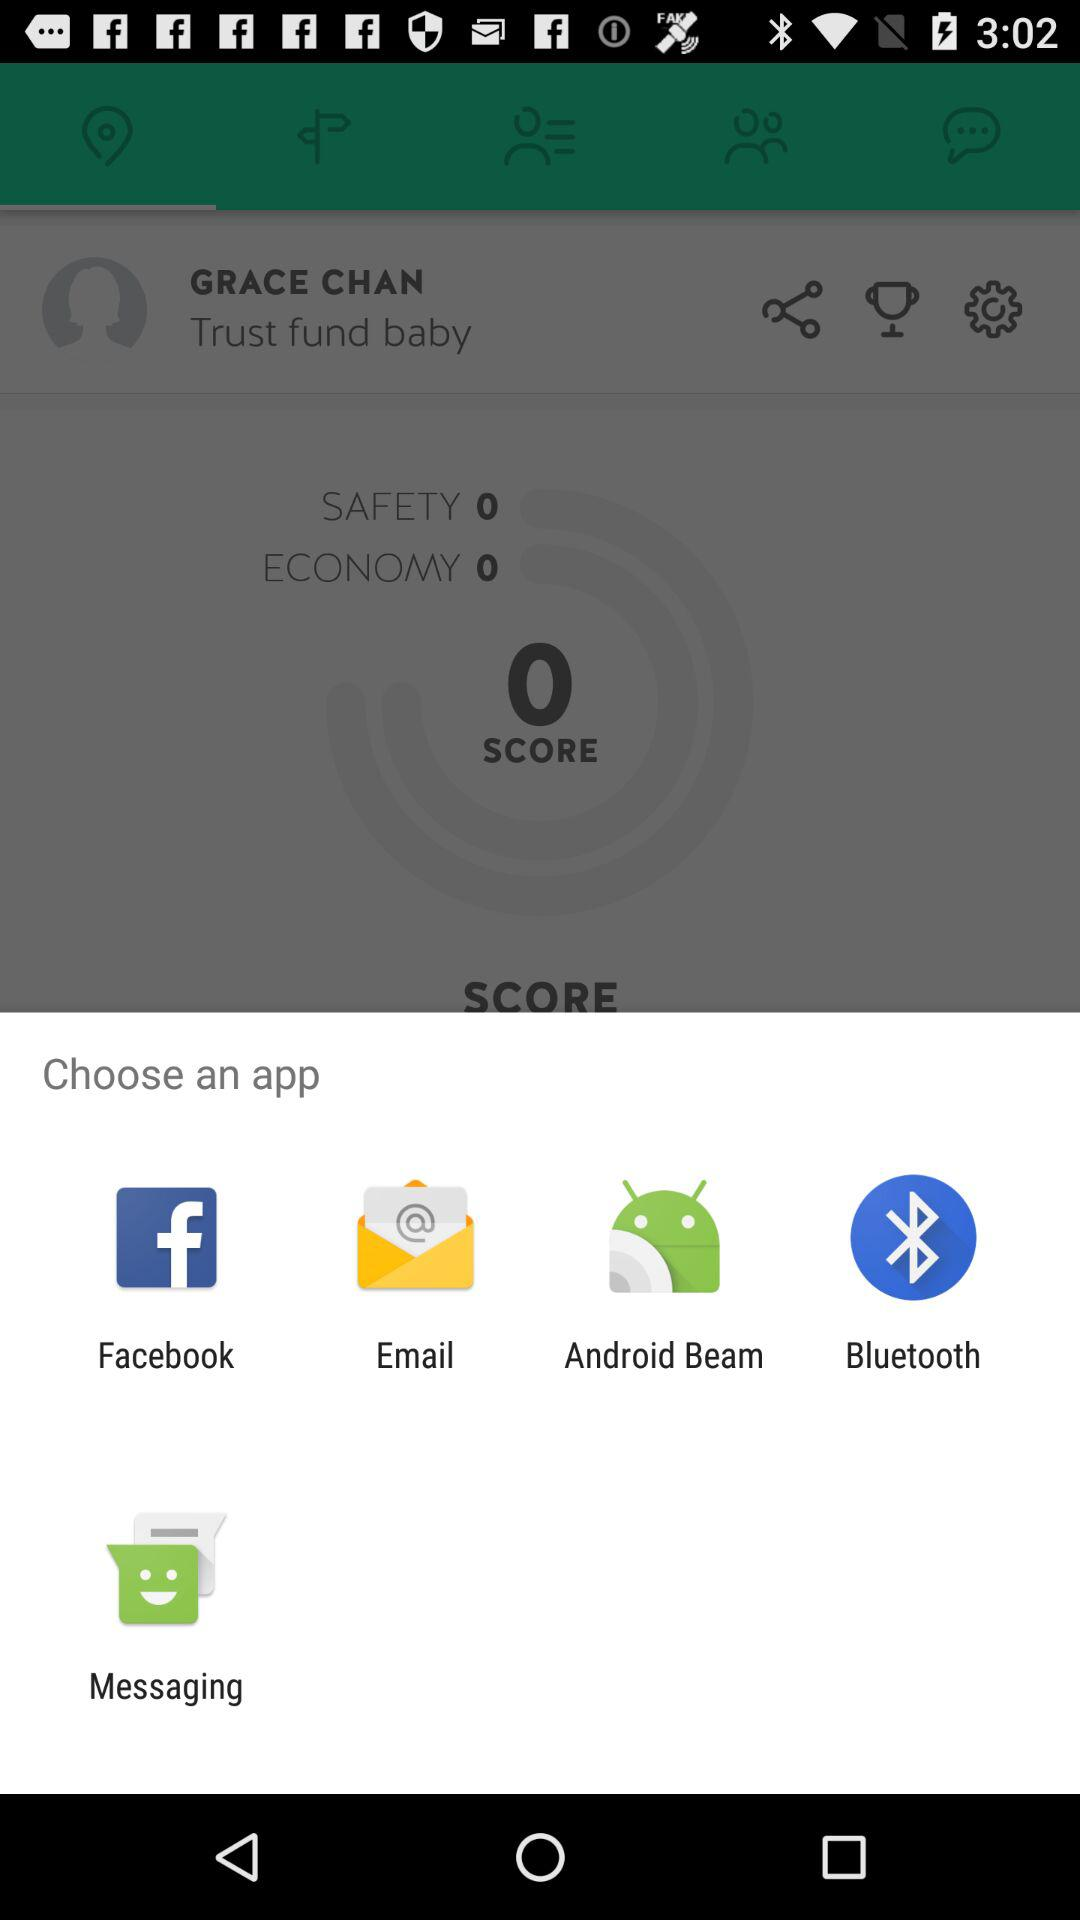What is the score? The score is 0. 